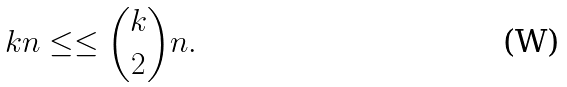Convert formula to latex. <formula><loc_0><loc_0><loc_500><loc_500>k n \leq \leq \binom { k } { 2 } n .</formula> 